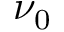Convert formula to latex. <formula><loc_0><loc_0><loc_500><loc_500>\nu _ { 0 }</formula> 